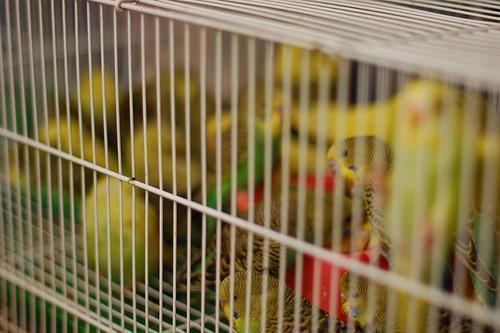How many different types of animals are there?
Give a very brief answer. 1. 